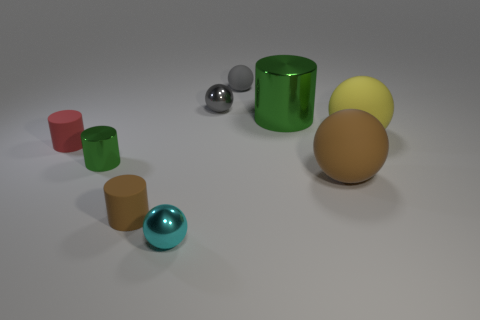Assuming these objects have different weights, in what order would you arrange them from lightest to heaviest? Based solely on the visual appearance, and assuming they are made from materials typically associated with their looks, I would speculate that the smallest red and brown cylinders are the lightest, followed by the medium-sized spheres and cyan-colored cylinders. The large green cylinder and the large beige sphere may be the heaviest objects. This order assumes common materials like plastics for smaller objects and metals or dense material for the larger ones. 